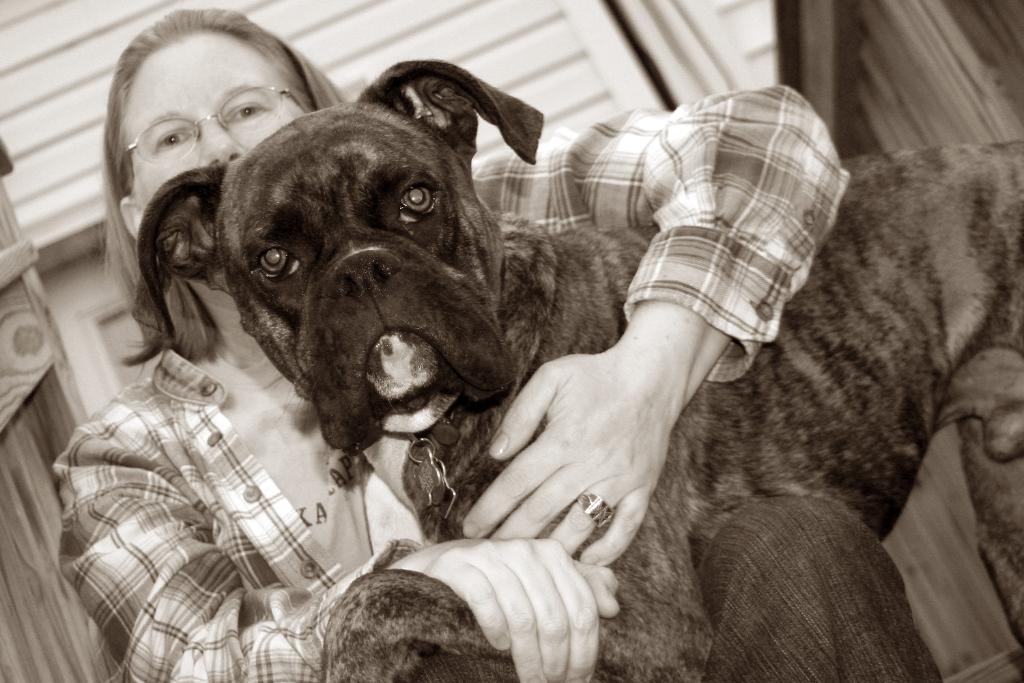Could you give a brief overview of what you see in this image? In the center of the image there is a dog. There is lady who is wearing a glasses is holding a dog in her hands. 